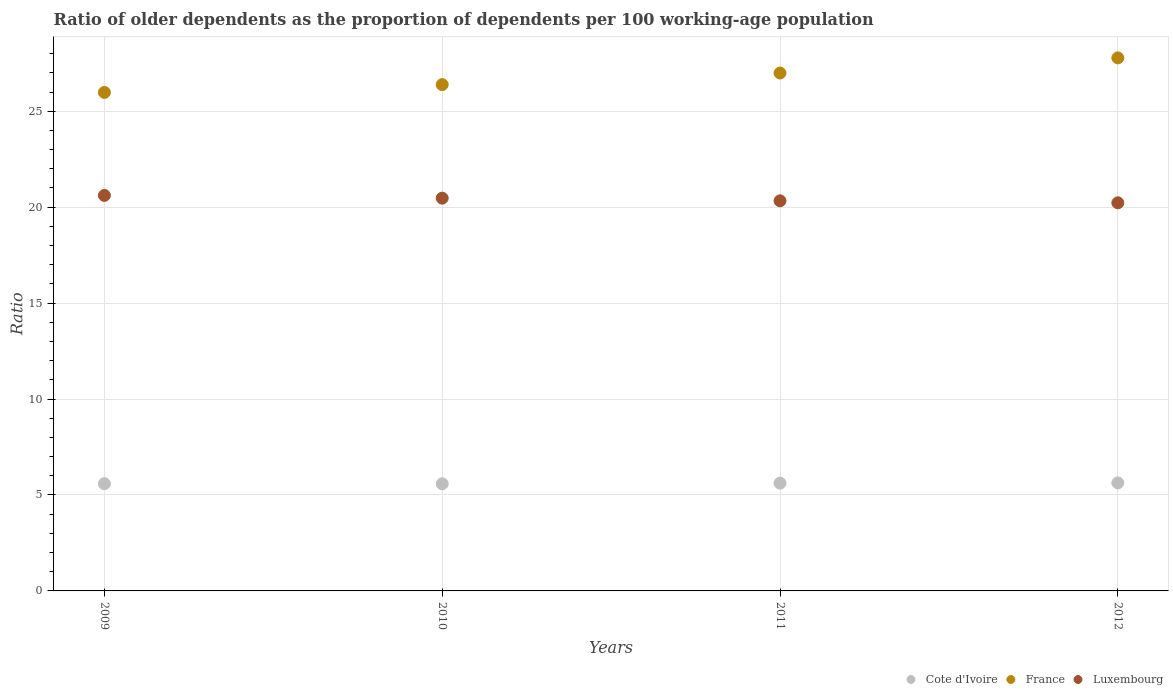How many different coloured dotlines are there?
Give a very brief answer. 3. Is the number of dotlines equal to the number of legend labels?
Offer a terse response. Yes. What is the age dependency ratio(old) in France in 2010?
Keep it short and to the point. 26.39. Across all years, what is the maximum age dependency ratio(old) in Luxembourg?
Keep it short and to the point. 20.61. Across all years, what is the minimum age dependency ratio(old) in France?
Offer a very short reply. 25.98. In which year was the age dependency ratio(old) in France minimum?
Ensure brevity in your answer.  2009. What is the total age dependency ratio(old) in Luxembourg in the graph?
Provide a succinct answer. 81.64. What is the difference between the age dependency ratio(old) in Cote d'Ivoire in 2011 and that in 2012?
Give a very brief answer. -0.01. What is the difference between the age dependency ratio(old) in Luxembourg in 2011 and the age dependency ratio(old) in France in 2012?
Provide a succinct answer. -7.45. What is the average age dependency ratio(old) in Cote d'Ivoire per year?
Your answer should be very brief. 5.6. In the year 2011, what is the difference between the age dependency ratio(old) in Luxembourg and age dependency ratio(old) in Cote d'Ivoire?
Make the answer very short. 14.71. What is the ratio of the age dependency ratio(old) in France in 2010 to that in 2012?
Keep it short and to the point. 0.95. Is the age dependency ratio(old) in France in 2009 less than that in 2011?
Offer a very short reply. Yes. Is the difference between the age dependency ratio(old) in Luxembourg in 2009 and 2010 greater than the difference between the age dependency ratio(old) in Cote d'Ivoire in 2009 and 2010?
Give a very brief answer. Yes. What is the difference between the highest and the second highest age dependency ratio(old) in France?
Provide a short and direct response. 0.79. What is the difference between the highest and the lowest age dependency ratio(old) in Cote d'Ivoire?
Give a very brief answer. 0.05. In how many years, is the age dependency ratio(old) in France greater than the average age dependency ratio(old) in France taken over all years?
Your answer should be very brief. 2. Is the sum of the age dependency ratio(old) in Cote d'Ivoire in 2010 and 2011 greater than the maximum age dependency ratio(old) in France across all years?
Offer a terse response. No. Does the age dependency ratio(old) in Luxembourg monotonically increase over the years?
Offer a very short reply. No. Is the age dependency ratio(old) in France strictly greater than the age dependency ratio(old) in Luxembourg over the years?
Offer a terse response. Yes. How many years are there in the graph?
Your answer should be compact. 4. What is the difference between two consecutive major ticks on the Y-axis?
Offer a terse response. 5. Does the graph contain any zero values?
Provide a short and direct response. No. Does the graph contain grids?
Give a very brief answer. Yes. What is the title of the graph?
Your answer should be very brief. Ratio of older dependents as the proportion of dependents per 100 working-age population. What is the label or title of the Y-axis?
Keep it short and to the point. Ratio. What is the Ratio of Cote d'Ivoire in 2009?
Provide a succinct answer. 5.59. What is the Ratio of France in 2009?
Provide a short and direct response. 25.98. What is the Ratio of Luxembourg in 2009?
Offer a terse response. 20.61. What is the Ratio in Cote d'Ivoire in 2010?
Keep it short and to the point. 5.58. What is the Ratio in France in 2010?
Keep it short and to the point. 26.39. What is the Ratio of Luxembourg in 2010?
Keep it short and to the point. 20.47. What is the Ratio in Cote d'Ivoire in 2011?
Ensure brevity in your answer.  5.62. What is the Ratio in France in 2011?
Your response must be concise. 26.99. What is the Ratio of Luxembourg in 2011?
Provide a succinct answer. 20.33. What is the Ratio of Cote d'Ivoire in 2012?
Provide a short and direct response. 5.63. What is the Ratio in France in 2012?
Keep it short and to the point. 27.78. What is the Ratio of Luxembourg in 2012?
Provide a succinct answer. 20.23. Across all years, what is the maximum Ratio in Cote d'Ivoire?
Ensure brevity in your answer.  5.63. Across all years, what is the maximum Ratio of France?
Your response must be concise. 27.78. Across all years, what is the maximum Ratio of Luxembourg?
Offer a very short reply. 20.61. Across all years, what is the minimum Ratio of Cote d'Ivoire?
Give a very brief answer. 5.58. Across all years, what is the minimum Ratio in France?
Provide a succinct answer. 25.98. Across all years, what is the minimum Ratio in Luxembourg?
Give a very brief answer. 20.23. What is the total Ratio of Cote d'Ivoire in the graph?
Ensure brevity in your answer.  22.42. What is the total Ratio in France in the graph?
Keep it short and to the point. 107.13. What is the total Ratio in Luxembourg in the graph?
Offer a very short reply. 81.64. What is the difference between the Ratio of Cote d'Ivoire in 2009 and that in 2010?
Ensure brevity in your answer.  0.01. What is the difference between the Ratio in France in 2009 and that in 2010?
Your response must be concise. -0.41. What is the difference between the Ratio of Luxembourg in 2009 and that in 2010?
Your response must be concise. 0.14. What is the difference between the Ratio of Cote d'Ivoire in 2009 and that in 2011?
Keep it short and to the point. -0.03. What is the difference between the Ratio in France in 2009 and that in 2011?
Provide a short and direct response. -1.01. What is the difference between the Ratio of Luxembourg in 2009 and that in 2011?
Your answer should be compact. 0.28. What is the difference between the Ratio of Cote d'Ivoire in 2009 and that in 2012?
Keep it short and to the point. -0.04. What is the difference between the Ratio of France in 2009 and that in 2012?
Keep it short and to the point. -1.8. What is the difference between the Ratio in Luxembourg in 2009 and that in 2012?
Make the answer very short. 0.39. What is the difference between the Ratio in Cote d'Ivoire in 2010 and that in 2011?
Provide a succinct answer. -0.04. What is the difference between the Ratio of France in 2010 and that in 2011?
Provide a succinct answer. -0.6. What is the difference between the Ratio of Luxembourg in 2010 and that in 2011?
Offer a very short reply. 0.14. What is the difference between the Ratio in Cote d'Ivoire in 2010 and that in 2012?
Your response must be concise. -0.05. What is the difference between the Ratio in France in 2010 and that in 2012?
Make the answer very short. -1.39. What is the difference between the Ratio in Luxembourg in 2010 and that in 2012?
Keep it short and to the point. 0.24. What is the difference between the Ratio of Cote d'Ivoire in 2011 and that in 2012?
Ensure brevity in your answer.  -0.01. What is the difference between the Ratio in France in 2011 and that in 2012?
Make the answer very short. -0.79. What is the difference between the Ratio of Luxembourg in 2011 and that in 2012?
Your response must be concise. 0.1. What is the difference between the Ratio of Cote d'Ivoire in 2009 and the Ratio of France in 2010?
Provide a succinct answer. -20.8. What is the difference between the Ratio in Cote d'Ivoire in 2009 and the Ratio in Luxembourg in 2010?
Your response must be concise. -14.88. What is the difference between the Ratio in France in 2009 and the Ratio in Luxembourg in 2010?
Give a very brief answer. 5.51. What is the difference between the Ratio in Cote d'Ivoire in 2009 and the Ratio in France in 2011?
Your answer should be compact. -21.4. What is the difference between the Ratio in Cote d'Ivoire in 2009 and the Ratio in Luxembourg in 2011?
Offer a terse response. -14.74. What is the difference between the Ratio in France in 2009 and the Ratio in Luxembourg in 2011?
Give a very brief answer. 5.65. What is the difference between the Ratio in Cote d'Ivoire in 2009 and the Ratio in France in 2012?
Make the answer very short. -22.19. What is the difference between the Ratio in Cote d'Ivoire in 2009 and the Ratio in Luxembourg in 2012?
Your response must be concise. -14.64. What is the difference between the Ratio in France in 2009 and the Ratio in Luxembourg in 2012?
Ensure brevity in your answer.  5.75. What is the difference between the Ratio in Cote d'Ivoire in 2010 and the Ratio in France in 2011?
Give a very brief answer. -21.41. What is the difference between the Ratio in Cote d'Ivoire in 2010 and the Ratio in Luxembourg in 2011?
Provide a succinct answer. -14.75. What is the difference between the Ratio of France in 2010 and the Ratio of Luxembourg in 2011?
Ensure brevity in your answer.  6.06. What is the difference between the Ratio in Cote d'Ivoire in 2010 and the Ratio in France in 2012?
Provide a succinct answer. -22.2. What is the difference between the Ratio of Cote d'Ivoire in 2010 and the Ratio of Luxembourg in 2012?
Offer a very short reply. -14.64. What is the difference between the Ratio of France in 2010 and the Ratio of Luxembourg in 2012?
Your answer should be very brief. 6.16. What is the difference between the Ratio in Cote d'Ivoire in 2011 and the Ratio in France in 2012?
Provide a succinct answer. -22.16. What is the difference between the Ratio of Cote d'Ivoire in 2011 and the Ratio of Luxembourg in 2012?
Ensure brevity in your answer.  -14.61. What is the difference between the Ratio of France in 2011 and the Ratio of Luxembourg in 2012?
Ensure brevity in your answer.  6.76. What is the average Ratio in Cote d'Ivoire per year?
Offer a terse response. 5.6. What is the average Ratio of France per year?
Your answer should be very brief. 26.78. What is the average Ratio in Luxembourg per year?
Ensure brevity in your answer.  20.41. In the year 2009, what is the difference between the Ratio in Cote d'Ivoire and Ratio in France?
Your answer should be very brief. -20.39. In the year 2009, what is the difference between the Ratio in Cote d'Ivoire and Ratio in Luxembourg?
Keep it short and to the point. -15.02. In the year 2009, what is the difference between the Ratio in France and Ratio in Luxembourg?
Keep it short and to the point. 5.37. In the year 2010, what is the difference between the Ratio of Cote d'Ivoire and Ratio of France?
Offer a terse response. -20.8. In the year 2010, what is the difference between the Ratio of Cote d'Ivoire and Ratio of Luxembourg?
Ensure brevity in your answer.  -14.89. In the year 2010, what is the difference between the Ratio of France and Ratio of Luxembourg?
Make the answer very short. 5.92. In the year 2011, what is the difference between the Ratio in Cote d'Ivoire and Ratio in France?
Your answer should be very brief. -21.37. In the year 2011, what is the difference between the Ratio of Cote d'Ivoire and Ratio of Luxembourg?
Your answer should be very brief. -14.71. In the year 2011, what is the difference between the Ratio in France and Ratio in Luxembourg?
Give a very brief answer. 6.66. In the year 2012, what is the difference between the Ratio of Cote d'Ivoire and Ratio of France?
Keep it short and to the point. -22.15. In the year 2012, what is the difference between the Ratio in Cote d'Ivoire and Ratio in Luxembourg?
Ensure brevity in your answer.  -14.6. In the year 2012, what is the difference between the Ratio of France and Ratio of Luxembourg?
Make the answer very short. 7.55. What is the ratio of the Ratio in Cote d'Ivoire in 2009 to that in 2010?
Provide a short and direct response. 1. What is the ratio of the Ratio of France in 2009 to that in 2010?
Make the answer very short. 0.98. What is the ratio of the Ratio of Luxembourg in 2009 to that in 2010?
Offer a terse response. 1.01. What is the ratio of the Ratio in Cote d'Ivoire in 2009 to that in 2011?
Your answer should be very brief. 0.99. What is the ratio of the Ratio of France in 2009 to that in 2011?
Ensure brevity in your answer.  0.96. What is the ratio of the Ratio in Luxembourg in 2009 to that in 2011?
Offer a terse response. 1.01. What is the ratio of the Ratio of France in 2009 to that in 2012?
Your answer should be very brief. 0.94. What is the ratio of the Ratio in Luxembourg in 2009 to that in 2012?
Provide a short and direct response. 1.02. What is the ratio of the Ratio in France in 2010 to that in 2011?
Make the answer very short. 0.98. What is the ratio of the Ratio in Luxembourg in 2010 to that in 2011?
Your answer should be very brief. 1.01. What is the ratio of the Ratio in France in 2010 to that in 2012?
Keep it short and to the point. 0.95. What is the ratio of the Ratio of Cote d'Ivoire in 2011 to that in 2012?
Make the answer very short. 1. What is the ratio of the Ratio in France in 2011 to that in 2012?
Make the answer very short. 0.97. What is the difference between the highest and the second highest Ratio in Cote d'Ivoire?
Give a very brief answer. 0.01. What is the difference between the highest and the second highest Ratio in France?
Make the answer very short. 0.79. What is the difference between the highest and the second highest Ratio in Luxembourg?
Keep it short and to the point. 0.14. What is the difference between the highest and the lowest Ratio of Cote d'Ivoire?
Provide a succinct answer. 0.05. What is the difference between the highest and the lowest Ratio of France?
Give a very brief answer. 1.8. What is the difference between the highest and the lowest Ratio in Luxembourg?
Your answer should be very brief. 0.39. 